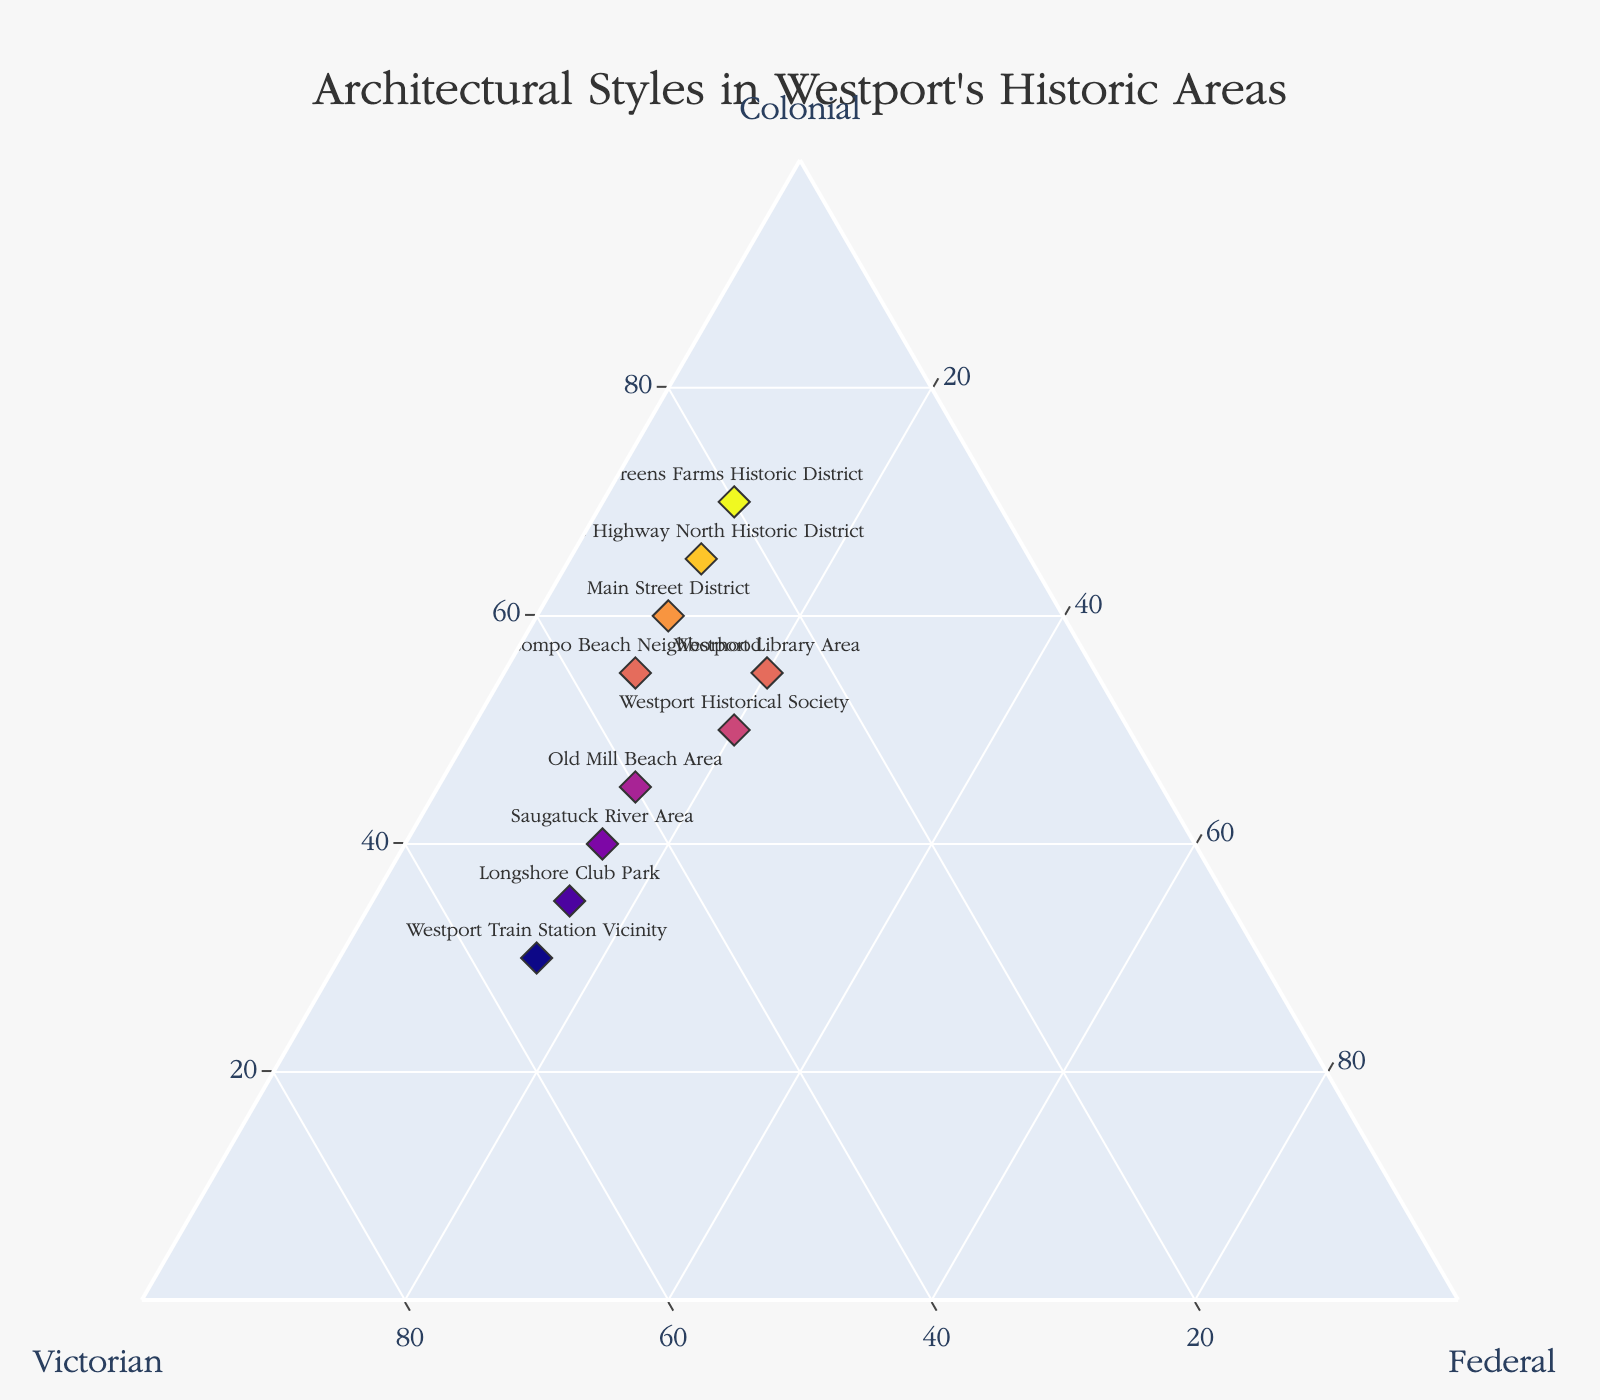What is the architectural style distribution at Main Street District? Look at the point labeled "Main Street District" and identify the values on each axis for Colonial, Victorian, and Federal.
Answer: 60% Colonial, 30% Victorian, 10% Federal Which location has the highest percentage of Victorian architecture? Identify the point with the maximum value on the Victorian axis (b-axis). The "Westport Train Station Vicinity" has the highest value in Victorian architecture.
Answer: Westport Train Station Vicinity What's the average percentage of Federal architecture across all locations? Sum the Federal percentages for all locations and divide by the number of locations. The sum is (10+15+10+10+10+20+15+15+20+15) = 140, and there are 10 locations. So, the average is 140/10 = 14%.
Answer: 14% Which location has an equal percentage of Colonial and Victorian architectures? Compare Colonial and Victorian values for all labeled points. The "Westport Historical Society" is the only location where Colonial and Victorian percentages are equal (both 30%).
Answer: Westport Historical Society What is the total percentage of Colonial architecture at Kings Highway North Historic District and Greens Farms Historic District combined? Add the values of Colonial architecture for both locations (65% for Kings Highway North Historic District and 70% for Greens Farms Historic District). 65 + 70 = 135.
Answer: 135% Which location has a higher percentage of Federal architecture, Saugatuck River Area or Old Mill Beach Area? Compare the Federal values of the two locations (15% for Saugatuck River Area and 15% for Old Mill Beach Area). Both have the same percentage.
Answer: Equal Which location stands closest to the centroid (having balanced distribution) among the three axes? Find the point closest to the center of the ternary plot, which represents a balanced distribution among the three architectural styles. "Westport Historical Society" stands closest to the centroid (50% Colonial, 30% Victorian, 20% Federal).
Answer: Westport Historical Society Calculate the difference in the Colonial architecture percentage between Compo Beach Neighborhood and Longshore Club Park. Subtract Longshore Club Park's Colonial percentage (35%) from Compo Beach Neighborhood's (55%). 55 - 35 = 20.
Answer: 20% Which has more balanced architecture distributions, Compo Beach Neighborhood or Westport Library Area? Compare the spread of percentages among Colonial, Victorian, and Federal for both locations. Westport Library Area (55% Colonial, 25% Victorian, 20% Federal) is more balanced compared to Compo Beach Neighborhood (55% Colonial, 35% Victorian, 10% Federal).
Answer: Westport Library Area What type of relationship do you observe when comparing the Colonial and Victorian percentages across all locations? Analyze if there's a trend or inverse relationship between Colonial and Victorian percentages among the data points, considering if high Colonial percentages correspond to low Victorian percentages and vice versa. Generally, a higher percentage in one often reflects a lower percentage in the other, showing an inverse relationship.
Answer: Inverse relationship 